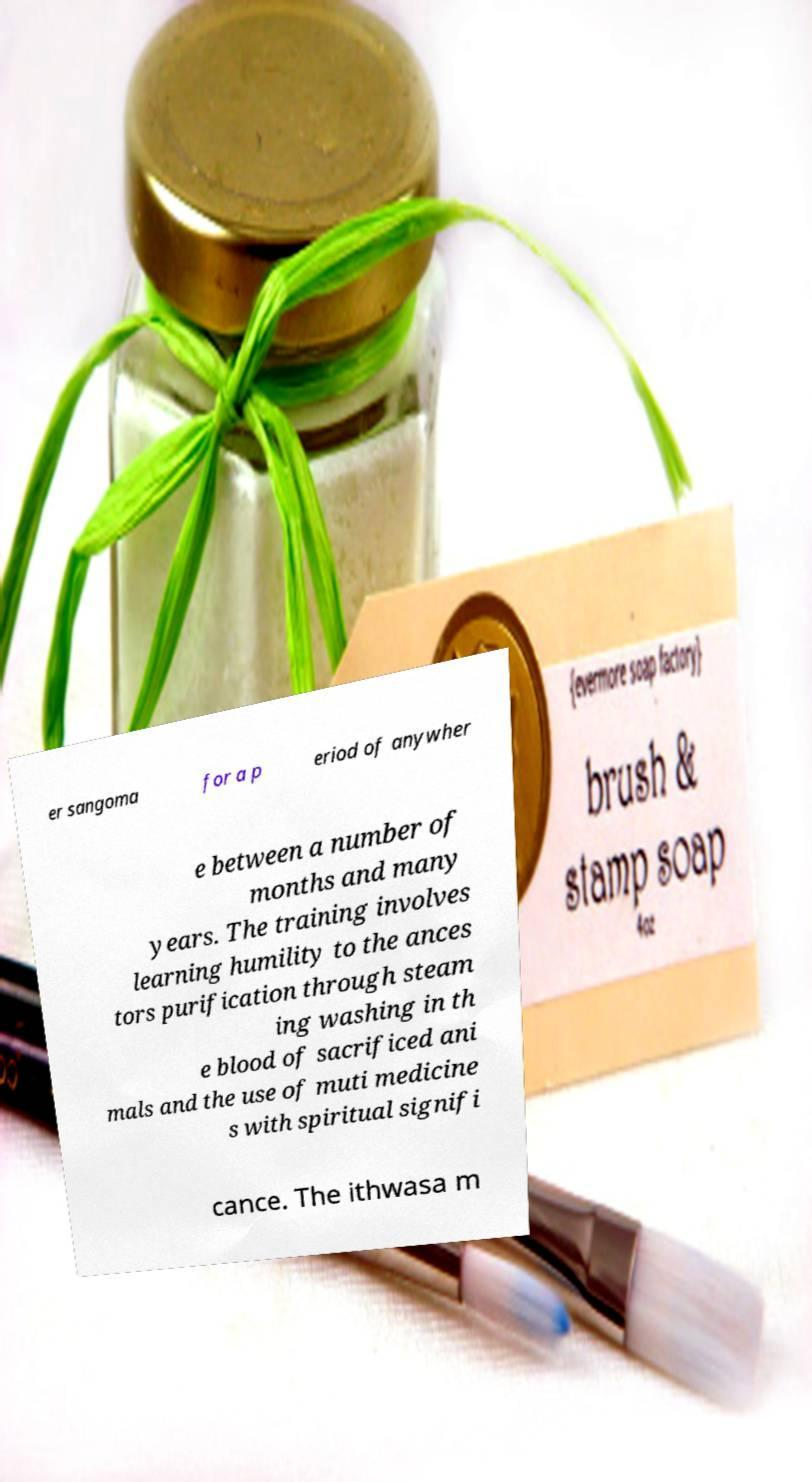For documentation purposes, I need the text within this image transcribed. Could you provide that? er sangoma for a p eriod of anywher e between a number of months and many years. The training involves learning humility to the ances tors purification through steam ing washing in th e blood of sacrificed ani mals and the use of muti medicine s with spiritual signifi cance. The ithwasa m 